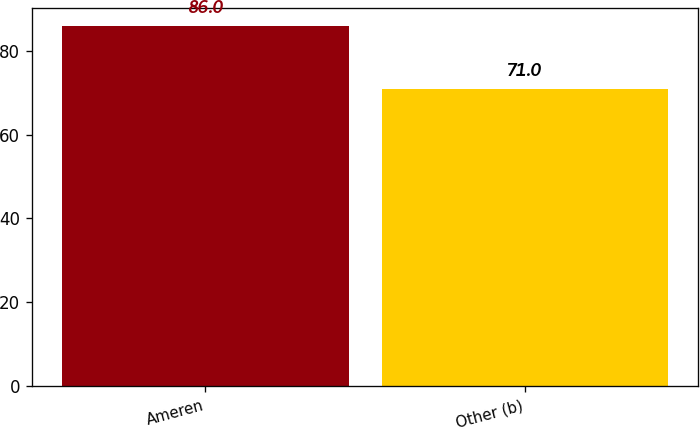Convert chart. <chart><loc_0><loc_0><loc_500><loc_500><bar_chart><fcel>Ameren<fcel>Other (b)<nl><fcel>86<fcel>71<nl></chart> 